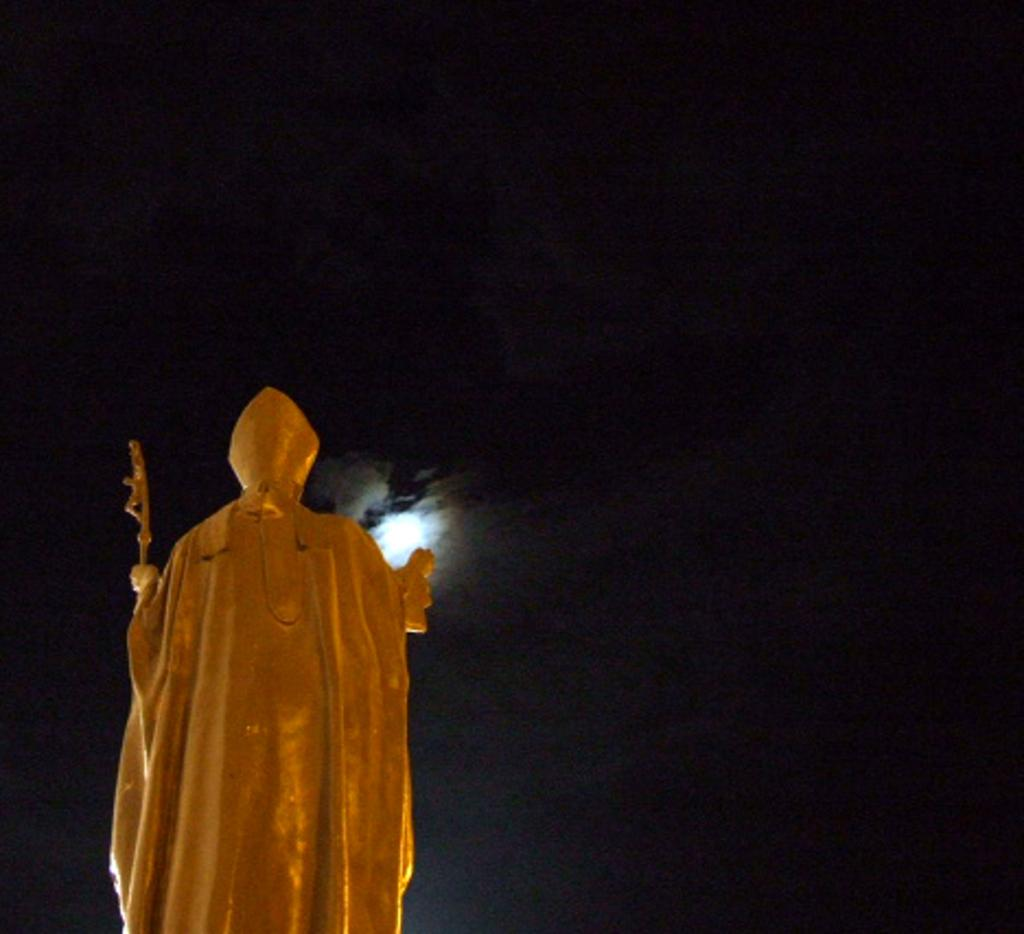What is the main subject of the image? There is a statue in the image. What is the statue wearing? The statue is wearing a cap. What is the statue holding in its hand? The statue is holding something in its hand. What can be seen in the background of the image? There is a light in the background of the image. How would you describe the lighting conditions in the image? The background of the image appears to be dark. What type of hospital can be seen in the image? There is no hospital present in the image; it features a statue with a cap and something in its hand. What effect does the statue have on the scale of the image? The statue does not affect the scale of the image, as it is a stationary object and does not change the size or perspective of the image. 